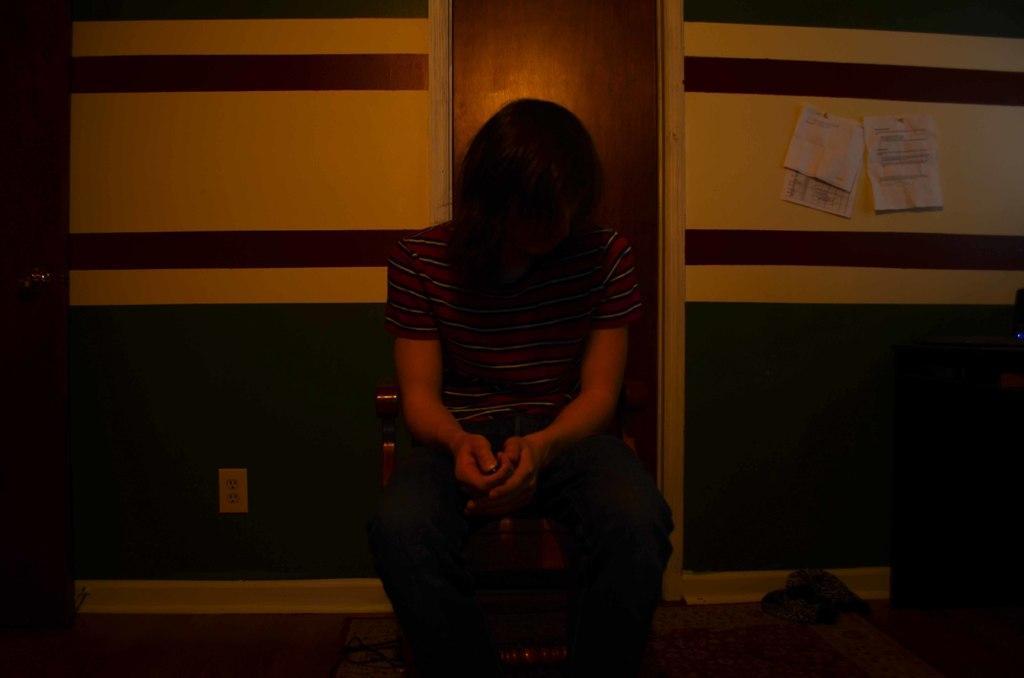Please provide a concise description of this image. In this image there is a person who is sitting on chair, background it may be the wooden door, wall, on the wall there are some papers attached on the right side. 